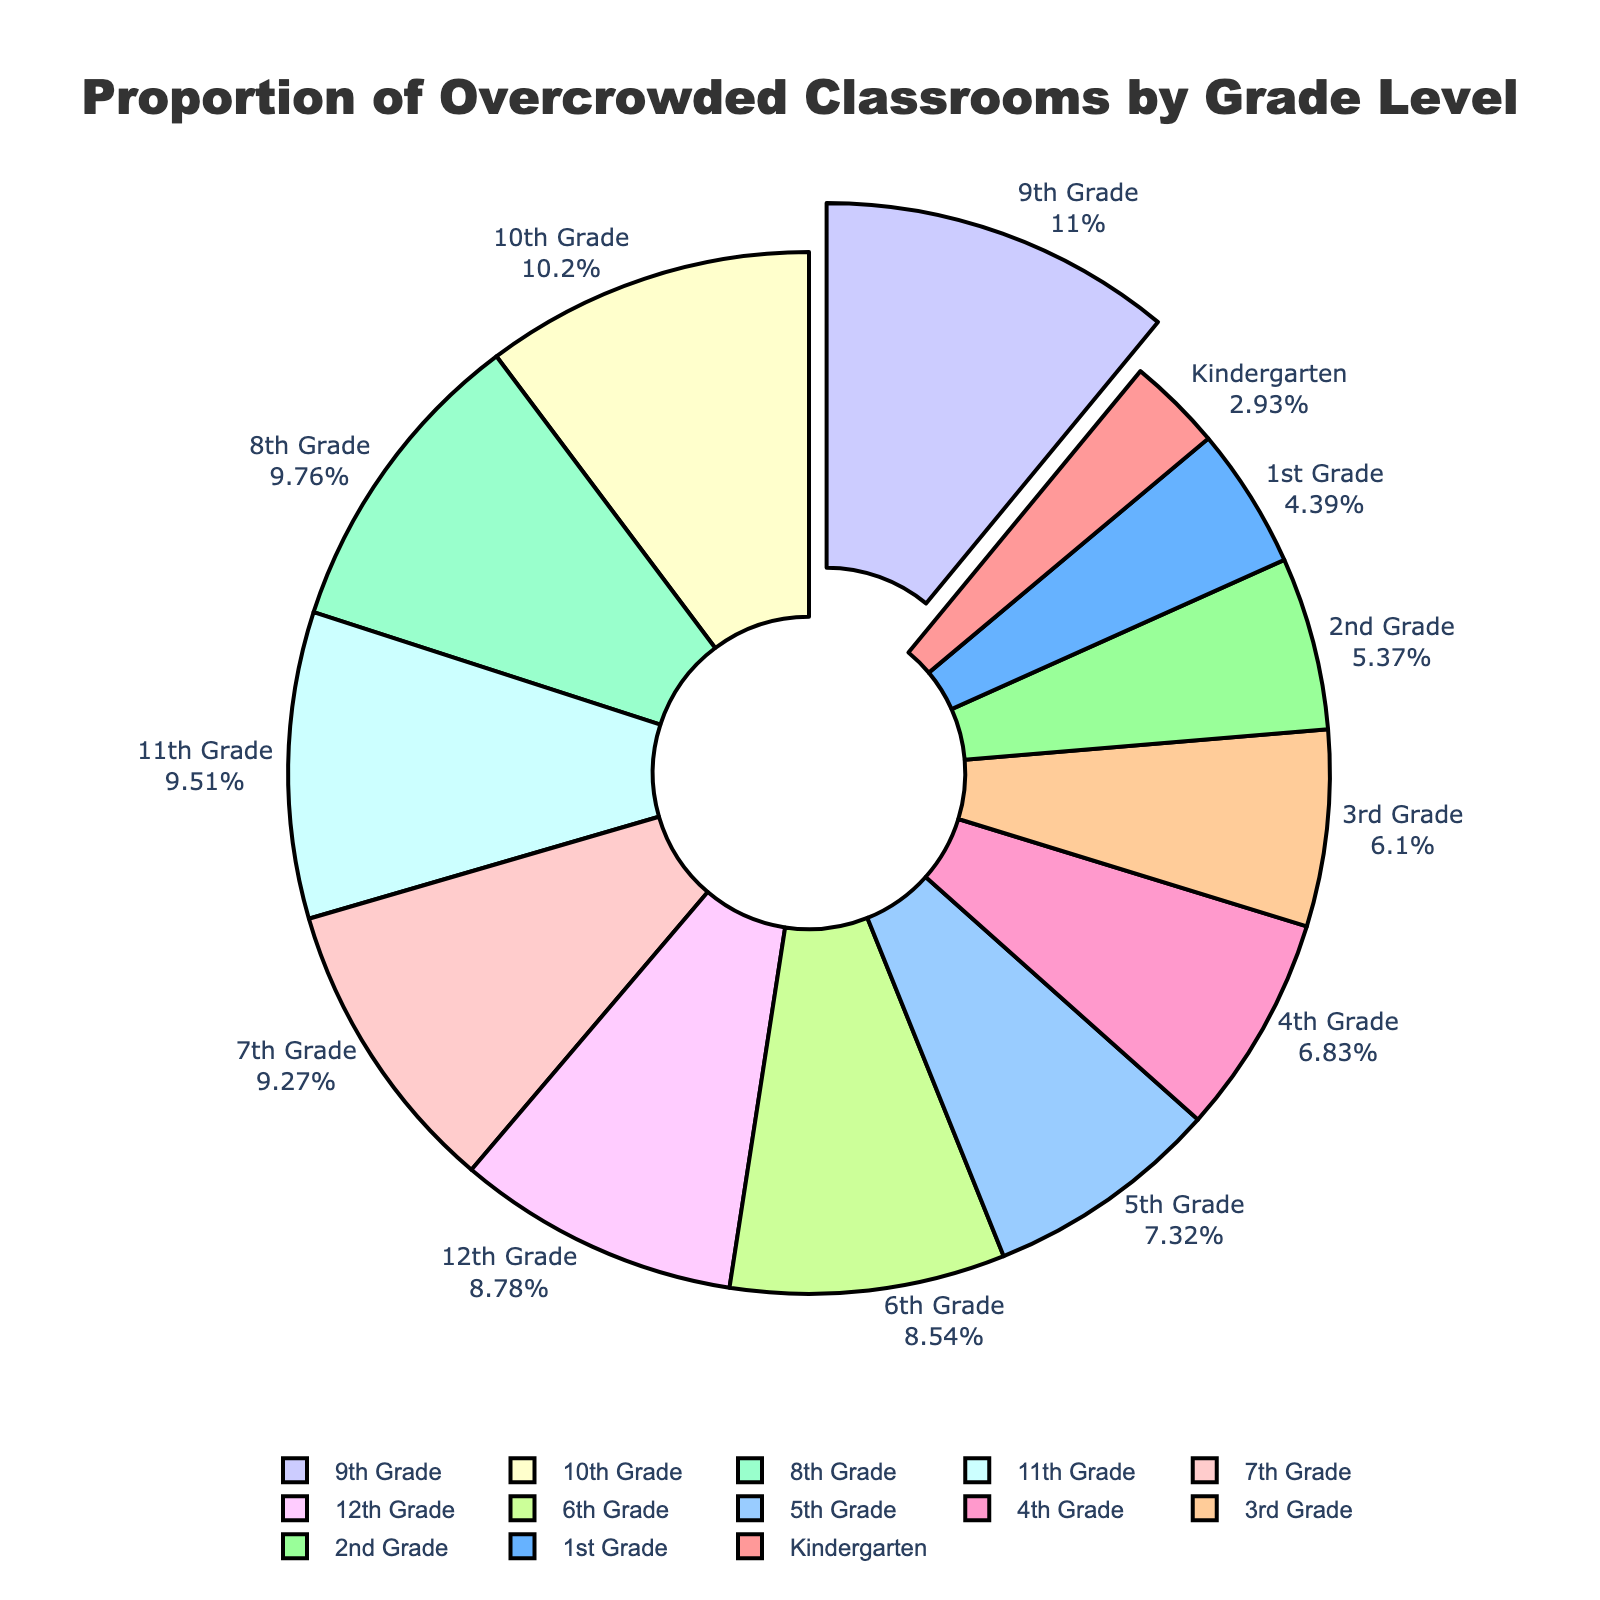What's the grade level with the highest percentage of overcrowded classrooms? By examining the chart, 9th Grade has the largest slice of the pie chart, labeled with the highest percentage.
Answer: 9th Grade Which grade level has a similar percentage of overcrowded classrooms to the 12th Grade? Looking at the pie chart, 11th Grade has a percentage of overcrowded classrooms (39%) that is close to 12th Grade's percentage (36%).
Answer: 11th Grade Compare the percentage of overcrowded classrooms in Kindergarten and 6th Grade. First, identify the slices for Kindergarten and 6th Grade on the pie chart. Kindergarten has 12%, while 6th Grade has 35%.
Answer: 6th Grade has higher percentage What's the sum of the percentages of overcrowded classrooms from Kindergarten to 3rd Grade? Add the percentages from Kindergarten (12%), 1st Grade (18%), 2nd Grade (22%), and 3rd Grade (25%). So, 12 + 18 + 22 + 25 = 77.
Answer: 77% What is the color of the slice representing 7th Grade's percentage of overcrowded classrooms? Find the label for 7th Grade on the pie chart and note its color. 7th Grade is represented with a light green color.
Answer: Light green Which grade levels have percentages of overcrowded classrooms greater than 30%? Look at the slices labeled with percentages greater than 30%. These are 7th Grade (38%), 8th Grade (40%), 9th Grade (45%), 10th Grade (42%), 11th Grade (39%), and 12th Grade (36%).
Answer: 7th, 8th, 9th, 10th, 11th, 12th Grades What is the median percentage of overcrowded classrooms from the given data? Arrange the percentages in ascending order: 12, 18, 22, 25, 28, 30, 35, 36, 38, 39, 40, 42, 45. The median is the middle value, which for 13 grades is the 7th value: 35.
Answer: 35% Compare the combined percentage of overcrowded classrooms for 3rd and 4th grades to that of 9th Grade. 3rd Grade (25%) + 4th Grade (28%) gives a combined percentage of 53%, which is higher than 9th Grade's percentage (45%).
Answer: Combined is higher 